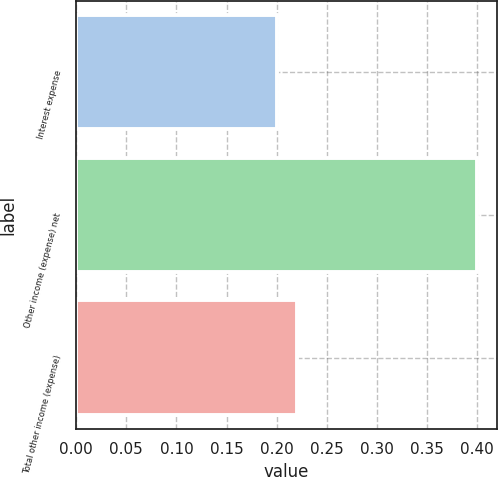Convert chart to OTSL. <chart><loc_0><loc_0><loc_500><loc_500><bar_chart><fcel>Interest expense<fcel>Other income (expense) net<fcel>Total other income (expense)<nl><fcel>0.2<fcel>0.4<fcel>0.22<nl></chart> 